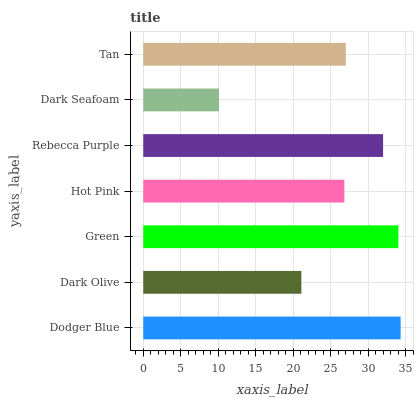Is Dark Seafoam the minimum?
Answer yes or no. Yes. Is Dodger Blue the maximum?
Answer yes or no. Yes. Is Dark Olive the minimum?
Answer yes or no. No. Is Dark Olive the maximum?
Answer yes or no. No. Is Dodger Blue greater than Dark Olive?
Answer yes or no. Yes. Is Dark Olive less than Dodger Blue?
Answer yes or no. Yes. Is Dark Olive greater than Dodger Blue?
Answer yes or no. No. Is Dodger Blue less than Dark Olive?
Answer yes or no. No. Is Tan the high median?
Answer yes or no. Yes. Is Tan the low median?
Answer yes or no. Yes. Is Dodger Blue the high median?
Answer yes or no. No. Is Dark Olive the low median?
Answer yes or no. No. 